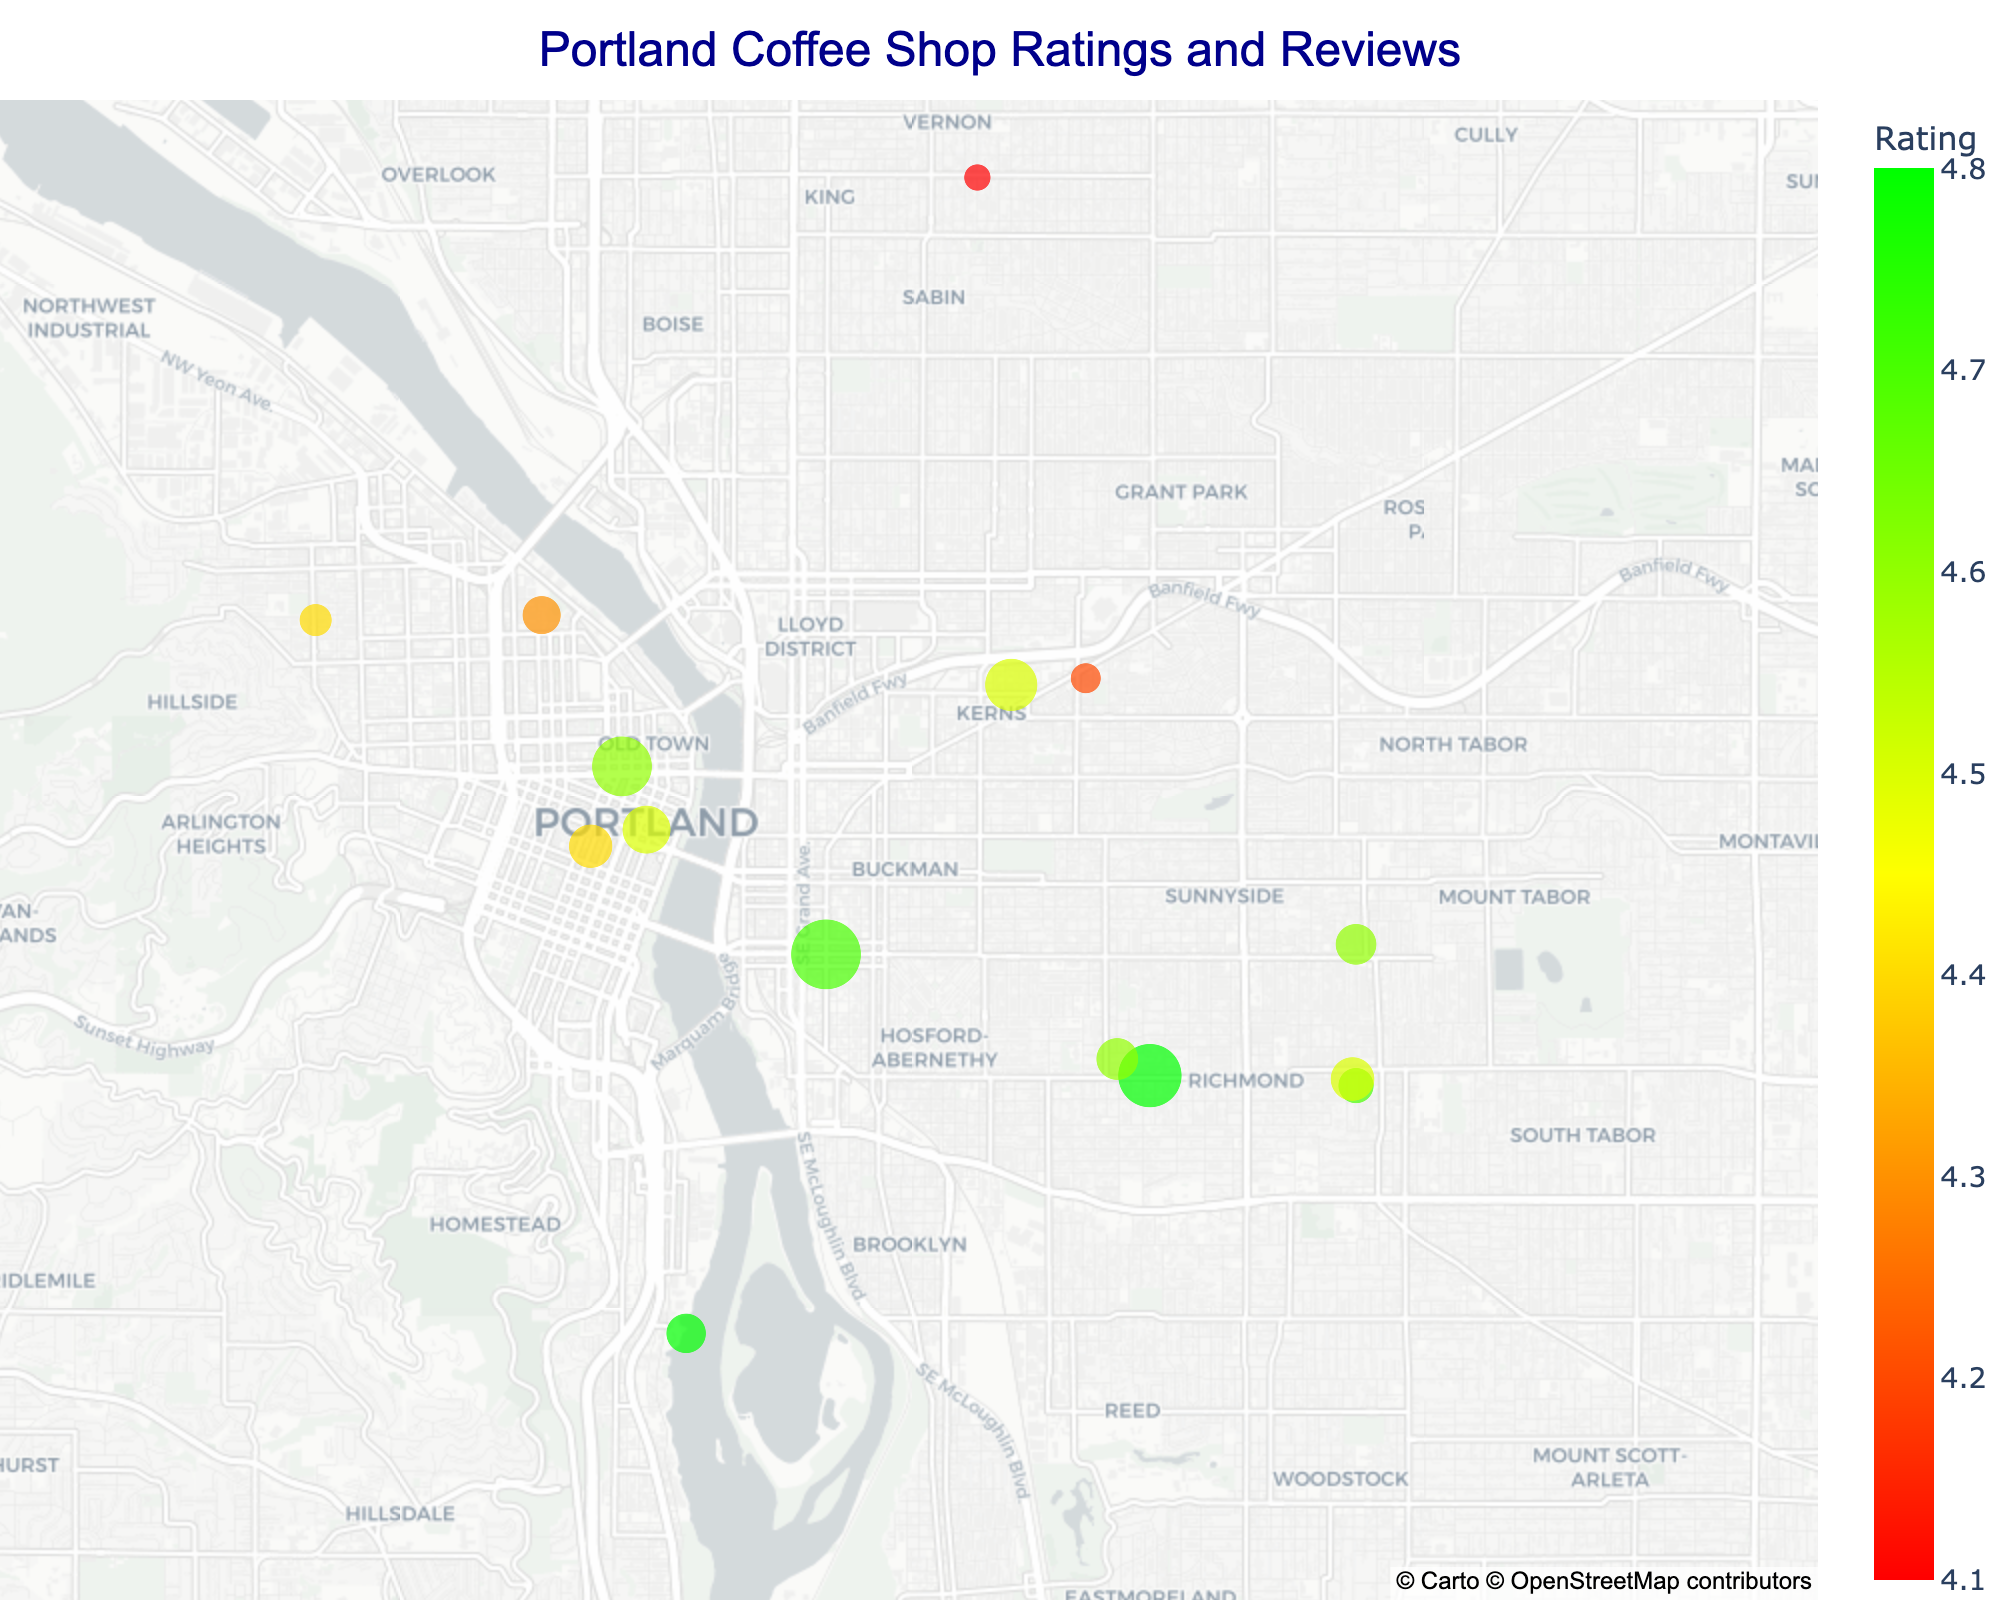What's the title of the figure? The title is typically displayed at the top of the figure and provides a summary of what the figure represents. In this case, it is "Portland Coffee Shop Ratings and Reviews."
Answer: Portland Coffee Shop Ratings and Reviews How many coffee shops are displayed on the map? By counting the number of distinct data points in the figure, we can determine that there are 15 coffee shops shown on the map.
Answer: 15 Which coffee shop has the highest rating? By examining the color gradient and hover information, Coava Coffee Roasters can be identified as the shop with the highest rating of 4.8.
Answer: Coava Coffee Roasters What is the average review count of all coffee shops? To find the average review count, sum all the review counts and divide by the number of shops. The total review count is 3219 (512 + 378 + 423 + 289 + 201 + 156 + 187 + 245 + 98 + 134 + 76 + 167 + 112 + 203 + 178), dividing by 15 gives an average of 214.6 reviews.
Answer: 214.6 reviews Which shop has the most number of reviews? Hovering over each data point reveals the number of reviews. Stumptown Coffee Roasters has the highest number of reviews at 512.
Answer: Stumptown Coffee Roasters Which area has a cluster of coffee shops with high ratings? By observing the clustering pattern and color gradient, the downtown area near the coordinates 45.5122, -122.6587 appears to have multiple high-rating coffee shops.
Answer: Downtown area What is the rating range between the highest and lowest rated coffee shops? The highest rating is 4.8 (Coava Coffee Roasters and Either/Or) and the lowest is 4.1 (Commissary Cafe). The range is calculated as 4.8 - 4.1.
Answer: 0.7 Identify the underserved area with fewer reviews and lower ratings. A cluster with lower reviews and less vibrant color (lower rating) can be observed around the coordinates 45.5589, -122.6457 (Commissary Cafe with 76 reviews and 4.1 rating).
Answer: Around 45.5589, -122.6457 Which coffee shop has the smallest number of reviews? By looking at the scatter plot's size attributes, Extracto Coffee Roasters can be identified as the one with the smallest number of reviews at 98.
Answer: Extracto Coffee Roasters How many shops have a rating of 4.6? By referring to the color scale and hover information of each shop, we find that three shops have a rating of 4.6 (Heart Coffee Roasters, Upper Left Roasters, Good Coffee).
Answer: 3 